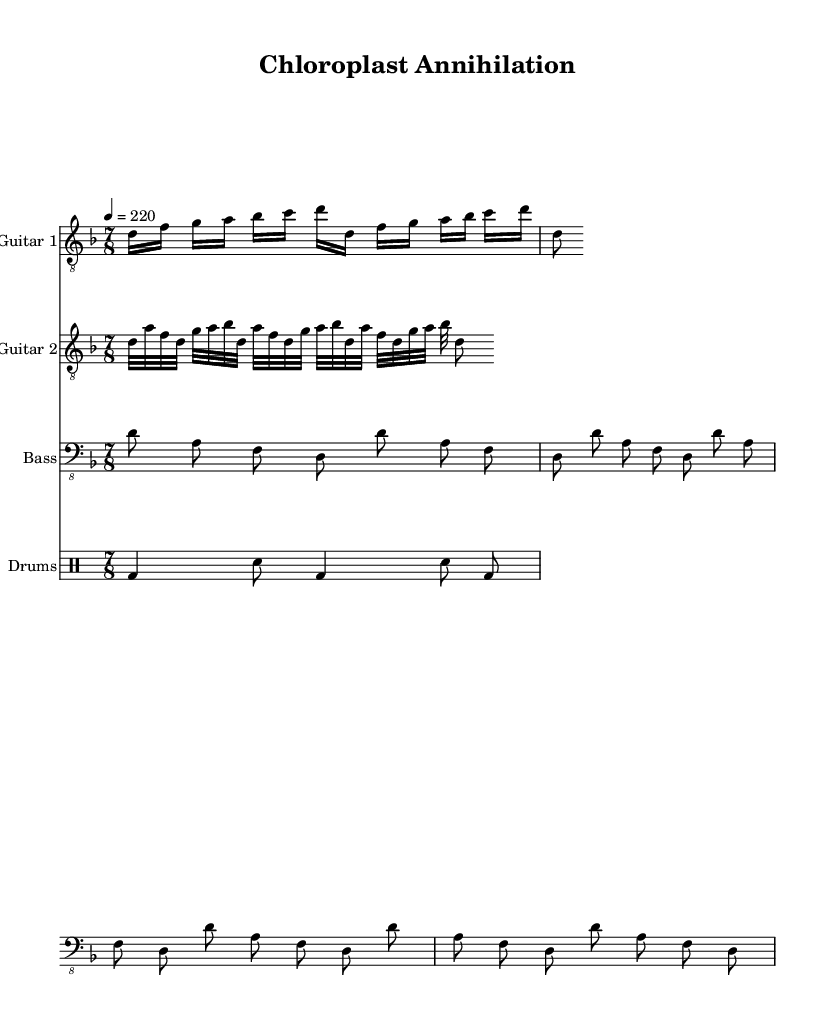What is the key signature of this music? The key signature is indicated at the beginning of the staff, and it is D minor, which has one flat (B flat).
Answer: D minor What is the time signature of this piece? The time signature is just after the key signature, shown as a fraction. Here, it is 7/8, which indicates there are seven eighth notes per measure.
Answer: 7/8 What is the tempo marking of this piece? The tempo is indicated as a numerical value with the word "tempo" next to it. In this case, it is marked as 4 = 220, meaning the quarter note equals 220 beats per minute.
Answer: 220 How many measures are there in Guitar 1? By counting the barlines in the staff for Guitar 1, we find there are 2 complete measures since there is no barline at the end of the last note in the repetition.
Answer: 2 Which instruments are featured in this score? The title of each staff shows the different instruments used in this score: Guitar 1, Guitar 2, Bass, and Drums, thus listing all featured instruments.
Answer: Guitar 1, Guitar 2, Bass, Drums What type of rhythm is primarily used in the bass guitar part? The rhythm in the bass guitar part is consistent, primarily using eighth notes throughout the measures. This creates a driving rhythm typical of metal music.
Answer: Eighth notes What kind of drumming pattern appears in this piece? The drumming pattern consists of a basic kick-snare pattern with different note values, and it is a common rhythm structure in metal music. Specifically, it alternates between bass drums and snare hits.
Answer: Kick-snare pattern 